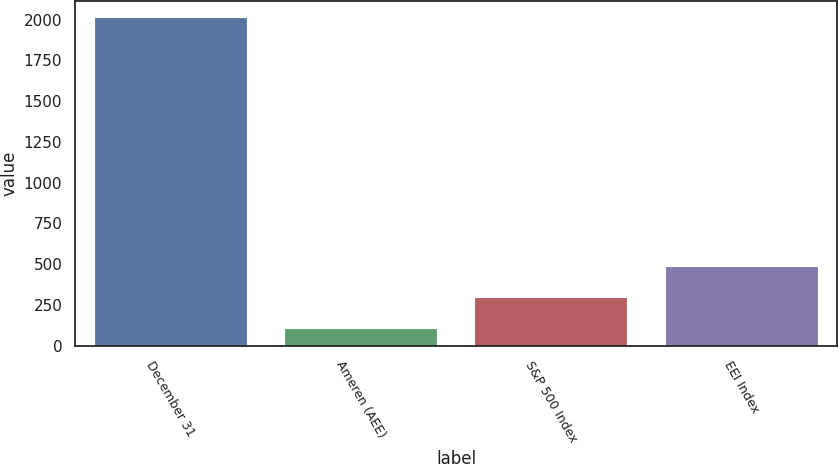<chart> <loc_0><loc_0><loc_500><loc_500><bar_chart><fcel>December 31<fcel>Ameren (AEE)<fcel>S&P 500 Index<fcel>EEI Index<nl><fcel>2013<fcel>100<fcel>291.3<fcel>482.6<nl></chart> 